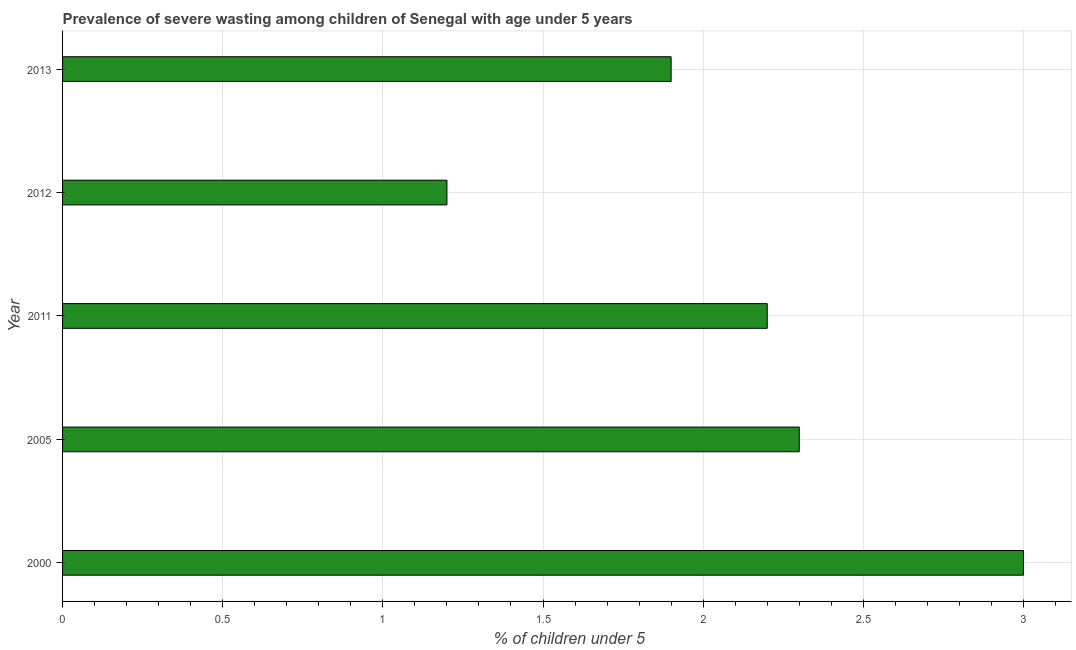Does the graph contain any zero values?
Provide a short and direct response. No. Does the graph contain grids?
Make the answer very short. Yes. What is the title of the graph?
Offer a very short reply. Prevalence of severe wasting among children of Senegal with age under 5 years. What is the label or title of the X-axis?
Your response must be concise.  % of children under 5. What is the prevalence of severe wasting in 2005?
Give a very brief answer. 2.3. Across all years, what is the maximum prevalence of severe wasting?
Make the answer very short. 3. Across all years, what is the minimum prevalence of severe wasting?
Your answer should be very brief. 1.2. What is the sum of the prevalence of severe wasting?
Make the answer very short. 10.6. What is the average prevalence of severe wasting per year?
Your response must be concise. 2.12. What is the median prevalence of severe wasting?
Your answer should be compact. 2.2. Do a majority of the years between 2011 and 2005 (inclusive) have prevalence of severe wasting greater than 1.2 %?
Your answer should be very brief. No. What is the ratio of the prevalence of severe wasting in 2011 to that in 2012?
Give a very brief answer. 1.83. Is the sum of the prevalence of severe wasting in 2005 and 2013 greater than the maximum prevalence of severe wasting across all years?
Your response must be concise. Yes. In how many years, is the prevalence of severe wasting greater than the average prevalence of severe wasting taken over all years?
Provide a short and direct response. 3. What is the difference between two consecutive major ticks on the X-axis?
Your answer should be very brief. 0.5. What is the  % of children under 5 in 2005?
Your response must be concise. 2.3. What is the  % of children under 5 of 2011?
Keep it short and to the point. 2.2. What is the  % of children under 5 in 2012?
Your response must be concise. 1.2. What is the  % of children under 5 in 2013?
Keep it short and to the point. 1.9. What is the difference between the  % of children under 5 in 2000 and 2012?
Your answer should be very brief. 1.8. What is the difference between the  % of children under 5 in 2005 and 2011?
Offer a terse response. 0.1. What is the difference between the  % of children under 5 in 2005 and 2013?
Your answer should be very brief. 0.4. What is the difference between the  % of children under 5 in 2011 and 2013?
Make the answer very short. 0.3. What is the ratio of the  % of children under 5 in 2000 to that in 2005?
Offer a very short reply. 1.3. What is the ratio of the  % of children under 5 in 2000 to that in 2011?
Ensure brevity in your answer.  1.36. What is the ratio of the  % of children under 5 in 2000 to that in 2012?
Ensure brevity in your answer.  2.5. What is the ratio of the  % of children under 5 in 2000 to that in 2013?
Your answer should be very brief. 1.58. What is the ratio of the  % of children under 5 in 2005 to that in 2011?
Make the answer very short. 1.04. What is the ratio of the  % of children under 5 in 2005 to that in 2012?
Make the answer very short. 1.92. What is the ratio of the  % of children under 5 in 2005 to that in 2013?
Keep it short and to the point. 1.21. What is the ratio of the  % of children under 5 in 2011 to that in 2012?
Provide a succinct answer. 1.83. What is the ratio of the  % of children under 5 in 2011 to that in 2013?
Provide a short and direct response. 1.16. What is the ratio of the  % of children under 5 in 2012 to that in 2013?
Provide a short and direct response. 0.63. 